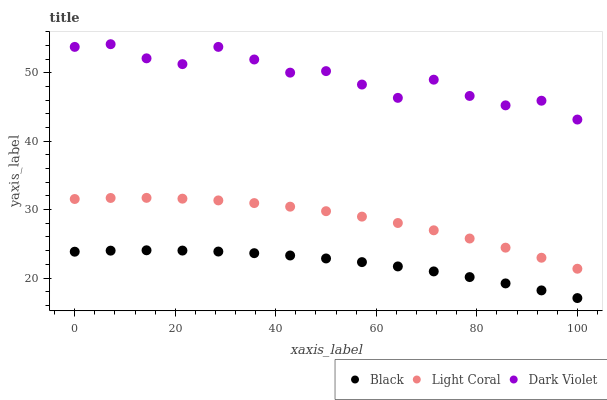Does Black have the minimum area under the curve?
Answer yes or no. Yes. Does Dark Violet have the maximum area under the curve?
Answer yes or no. Yes. Does Dark Violet have the minimum area under the curve?
Answer yes or no. No. Does Black have the maximum area under the curve?
Answer yes or no. No. Is Black the smoothest?
Answer yes or no. Yes. Is Dark Violet the roughest?
Answer yes or no. Yes. Is Dark Violet the smoothest?
Answer yes or no. No. Is Black the roughest?
Answer yes or no. No. Does Black have the lowest value?
Answer yes or no. Yes. Does Dark Violet have the lowest value?
Answer yes or no. No. Does Dark Violet have the highest value?
Answer yes or no. Yes. Does Black have the highest value?
Answer yes or no. No. Is Black less than Dark Violet?
Answer yes or no. Yes. Is Dark Violet greater than Light Coral?
Answer yes or no. Yes. Does Black intersect Dark Violet?
Answer yes or no. No. 